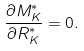<formula> <loc_0><loc_0><loc_500><loc_500>\frac { \partial { M _ { K } ^ { * } } } { \partial { R _ { K } ^ { * } } } = 0 .</formula> 